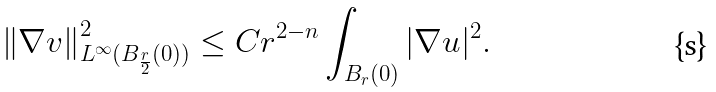Convert formula to latex. <formula><loc_0><loc_0><loc_500><loc_500>\left \| \nabla v \right \| ^ { 2 } _ { L ^ { \infty } ( B _ { \frac { r } 2 } ( 0 ) ) } \leq C r ^ { 2 - n } \int _ { B _ { r } ( 0 ) } | \nabla u | ^ { 2 } .</formula> 